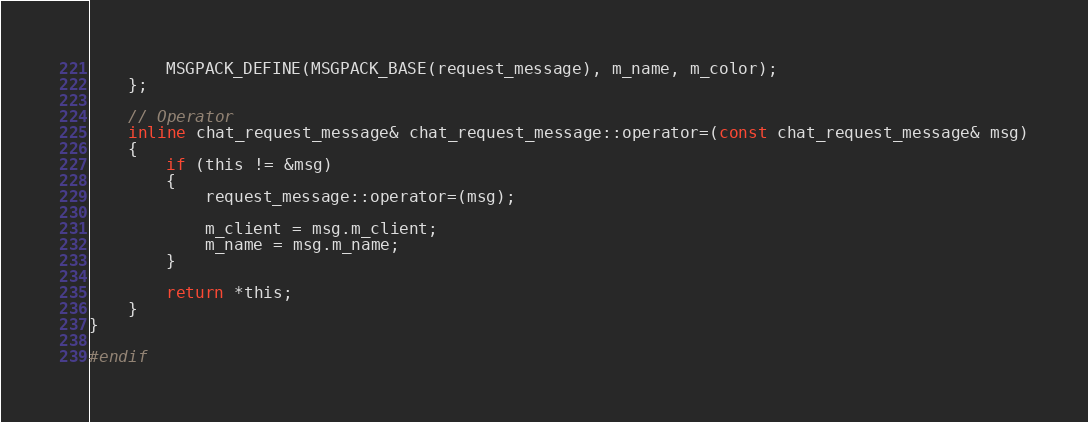<code> <loc_0><loc_0><loc_500><loc_500><_C_>
		MSGPACK_DEFINE(MSGPACK_BASE(request_message), m_name, m_color);
	};

	// Operator
	inline chat_request_message& chat_request_message::operator=(const chat_request_message& msg)
	{
		if (this != &msg)
		{
			request_message::operator=(msg);

			m_client = msg.m_client;
			m_name = msg.m_name;
		}

		return *this;
	}
}

#endif
</code> 